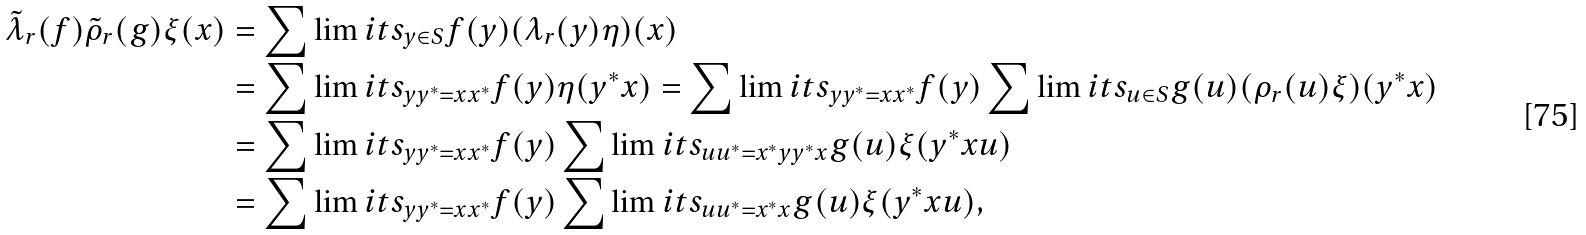<formula> <loc_0><loc_0><loc_500><loc_500>\tilde { \lambda } _ { r } ( f ) \tilde { \rho } _ { r } ( g ) \xi ( x ) & = \sum \lim i t s _ { y \in S } f ( y ) ( \lambda _ { r } ( y ) \eta ) ( x ) \\ & = \sum \lim i t s _ { y y ^ { * } = x x ^ { * } } f ( y ) \eta ( y ^ { * } x ) = \sum \lim i t s _ { y y ^ { * } = x x ^ { * } } f ( y ) \sum \lim i t s _ { u \in S } g ( u ) ( \rho _ { r } ( u ) \xi ) ( y ^ { * } x ) \\ & = \sum \lim i t s _ { y y ^ { * } = x x ^ { * } } f ( y ) \sum \lim i t s _ { u u ^ { * } = x ^ { * } y y ^ { * } x } g ( u ) \xi ( y ^ { * } x u ) \\ & = \sum \lim i t s _ { y y ^ { * } = x x ^ { * } } f ( y ) \sum \lim i t s _ { u u ^ { * } = x ^ { * } x } g ( u ) \xi ( y ^ { * } x u ) ,</formula> 